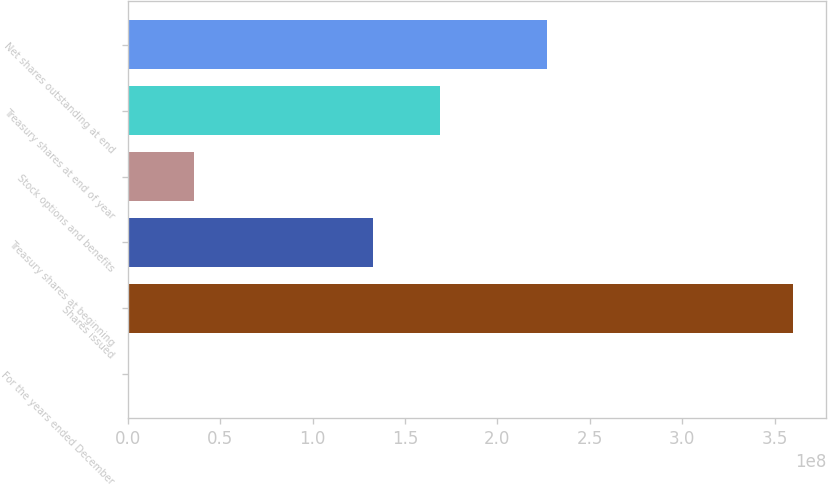Convert chart. <chart><loc_0><loc_0><loc_500><loc_500><bar_chart><fcel>For the years ended December<fcel>Shares issued<fcel>Treasury shares at beginning<fcel>Stock options and benefits<fcel>Treasury shares at end of year<fcel>Net shares outstanding at end<nl><fcel>2008<fcel>3.59902e+08<fcel>1.32852e+08<fcel>3.5992e+07<fcel>1.68842e+08<fcel>2.27035e+08<nl></chart> 